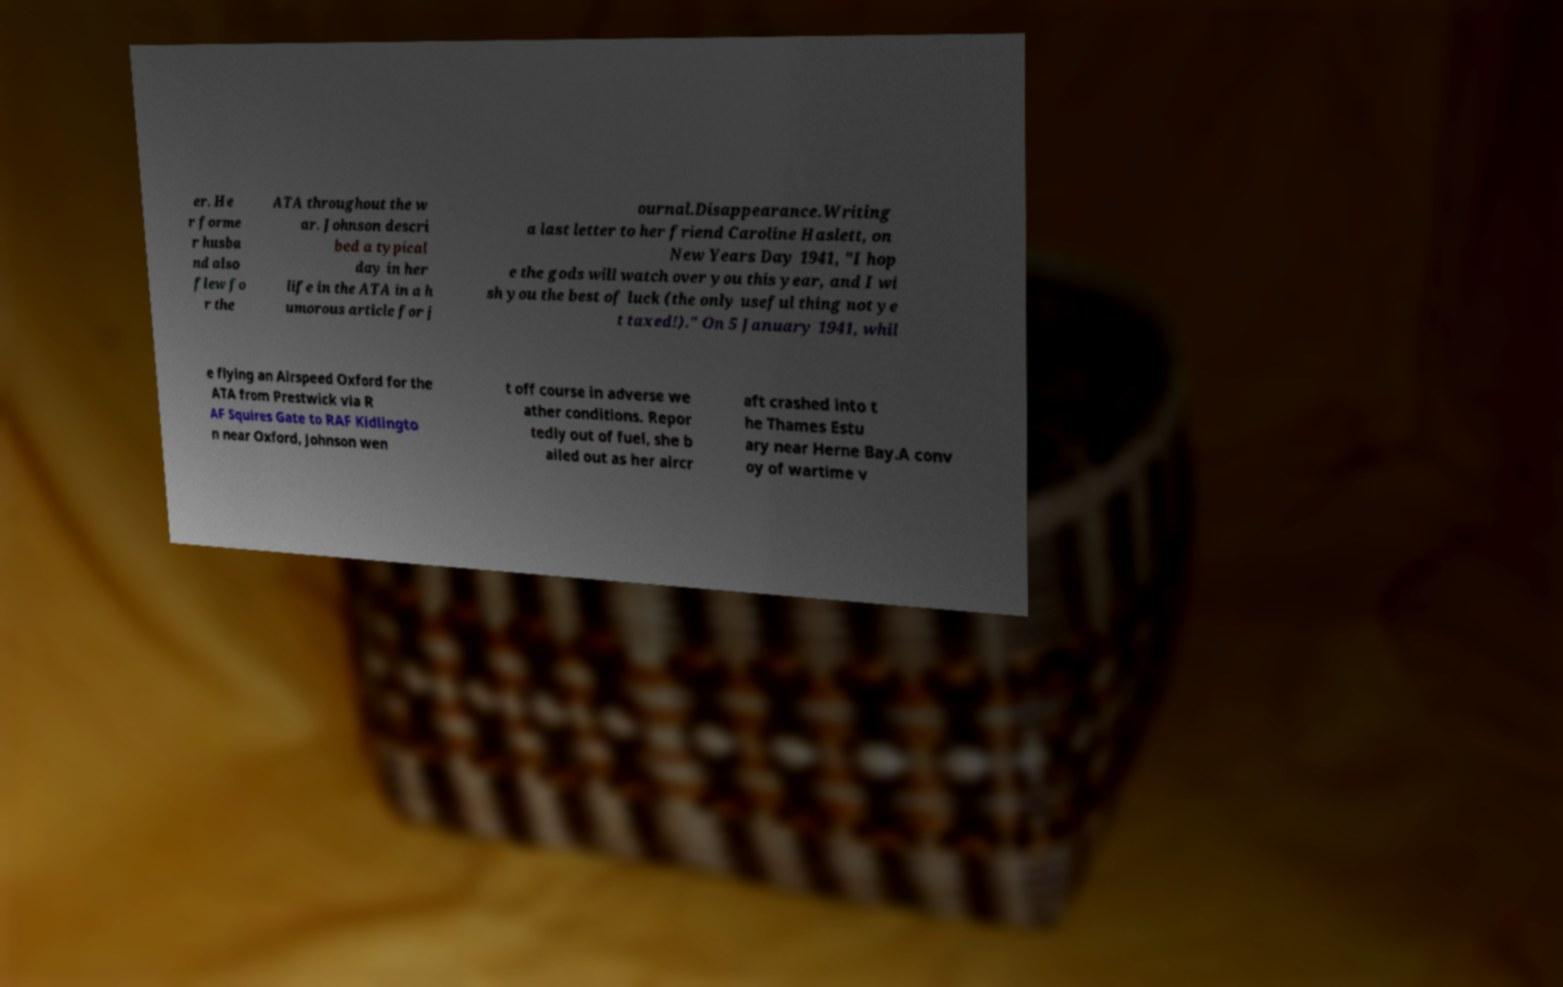What messages or text are displayed in this image? I need them in a readable, typed format. er. He r forme r husba nd also flew fo r the ATA throughout the w ar. Johnson descri bed a typical day in her life in the ATA in a h umorous article for j ournal.Disappearance.Writing a last letter to her friend Caroline Haslett, on New Years Day 1941, "I hop e the gods will watch over you this year, and I wi sh you the best of luck (the only useful thing not ye t taxed!)." On 5 January 1941, whil e flying an Airspeed Oxford for the ATA from Prestwick via R AF Squires Gate to RAF Kidlingto n near Oxford, Johnson wen t off course in adverse we ather conditions. Repor tedly out of fuel, she b ailed out as her aircr aft crashed into t he Thames Estu ary near Herne Bay.A conv oy of wartime v 